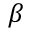<formula> <loc_0><loc_0><loc_500><loc_500>\beta</formula> 